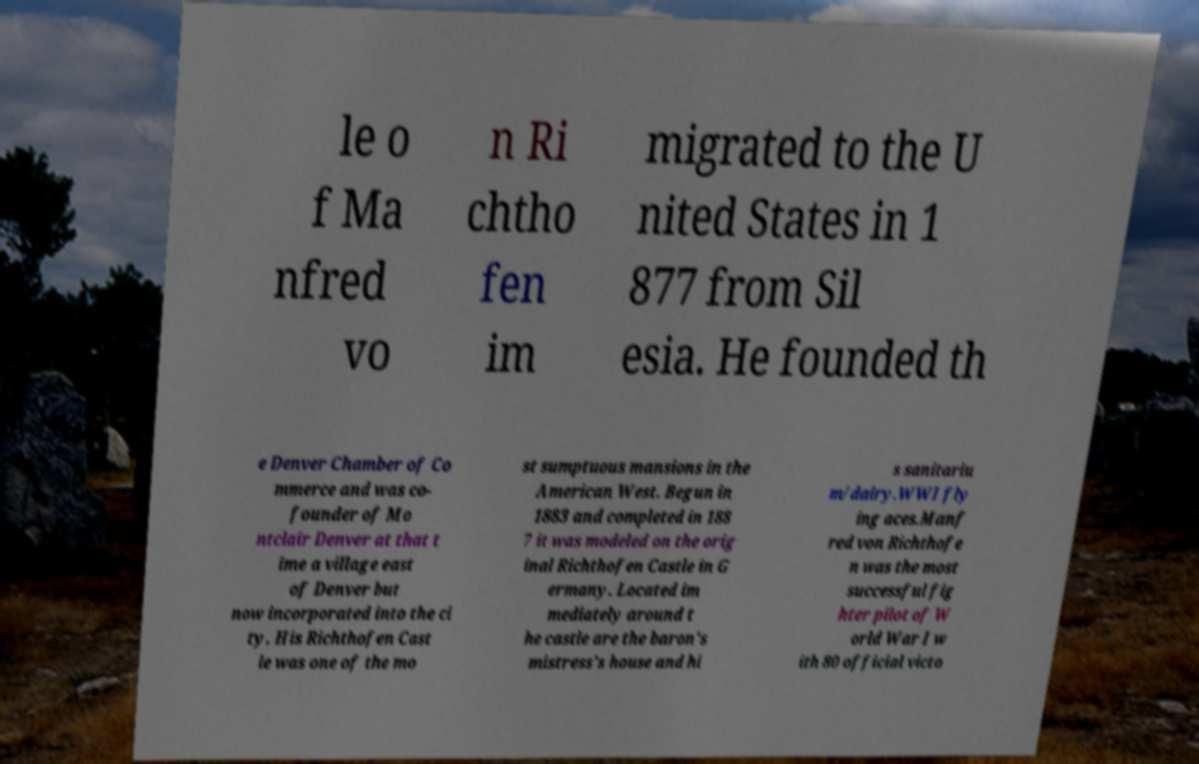For documentation purposes, I need the text within this image transcribed. Could you provide that? le o f Ma nfred vo n Ri chtho fen im migrated to the U nited States in 1 877 from Sil esia. He founded th e Denver Chamber of Co mmerce and was co- founder of Mo ntclair Denver at that t ime a village east of Denver but now incorporated into the ci ty. His Richthofen Cast le was one of the mo st sumptuous mansions in the American West. Begun in 1883 and completed in 188 7 it was modeled on the orig inal Richthofen Castle in G ermany. Located im mediately around t he castle are the baron's mistress's house and hi s sanitariu m/dairy.WWI fly ing aces.Manf red von Richthofe n was the most successful fig hter pilot of W orld War I w ith 80 official victo 